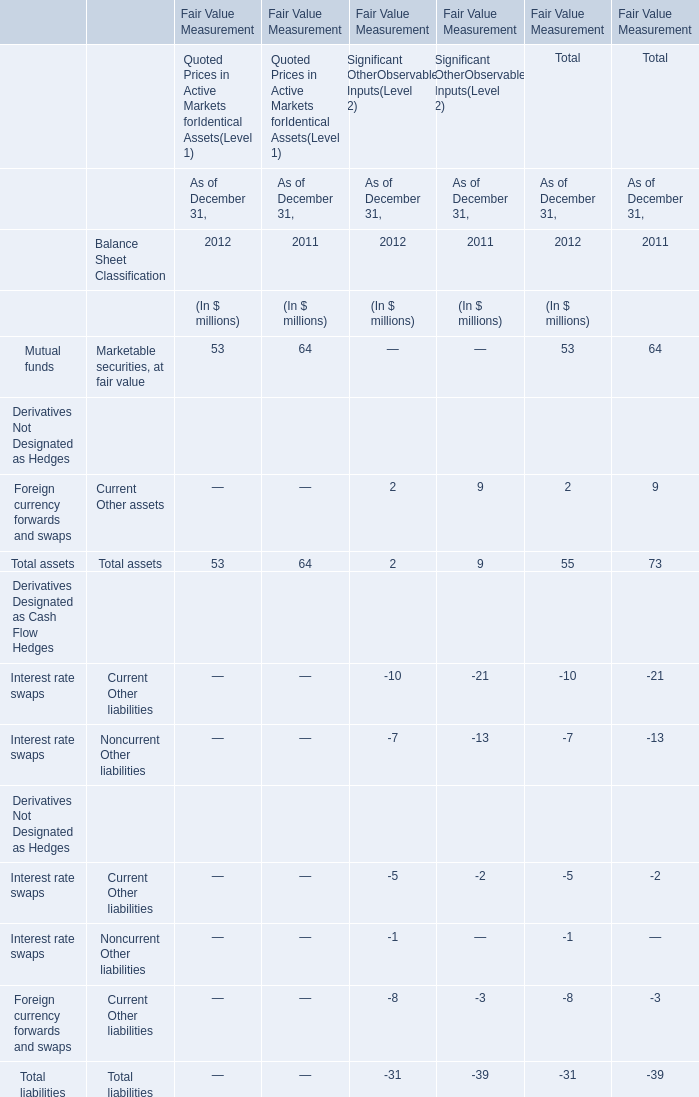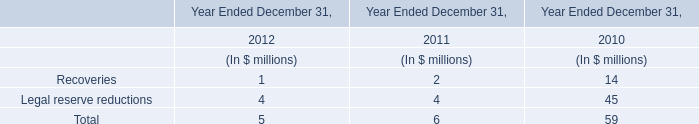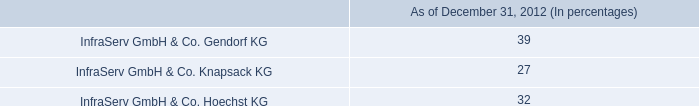what is the percentage change in the cash dividends received by the company in 2011 compare to 2010? 
Computations: ((78 - 71) / 71)
Answer: 0.09859. 